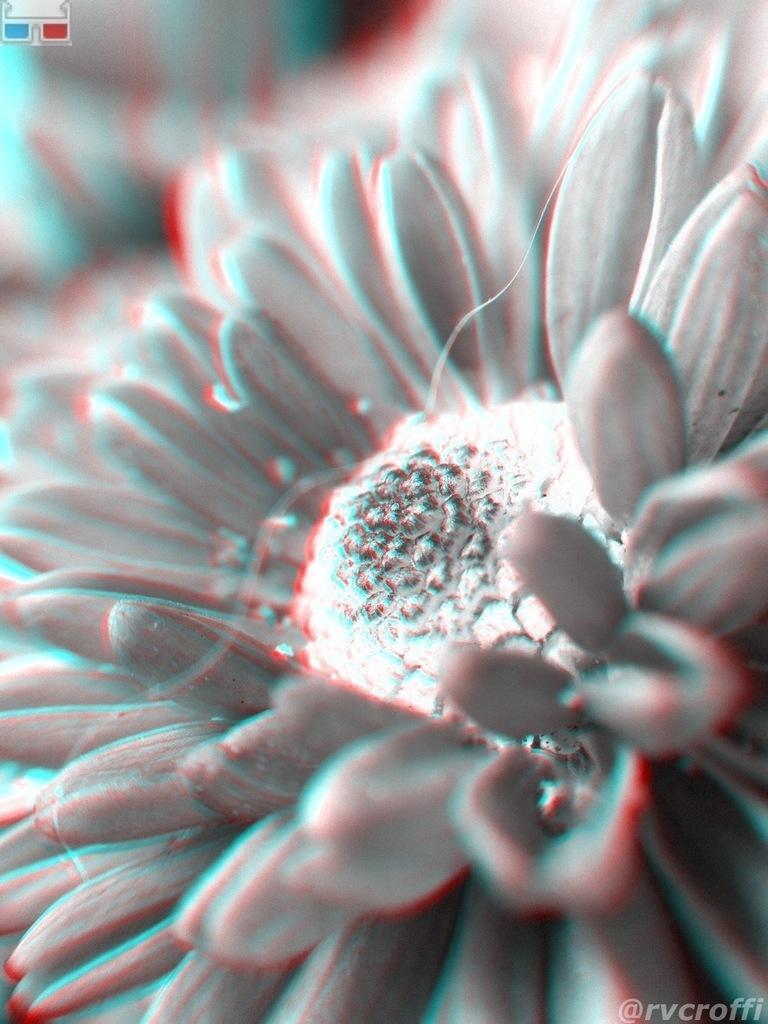How would you summarize this image in a sentence or two? This is an edited picture. In this picture we can see a flower. 